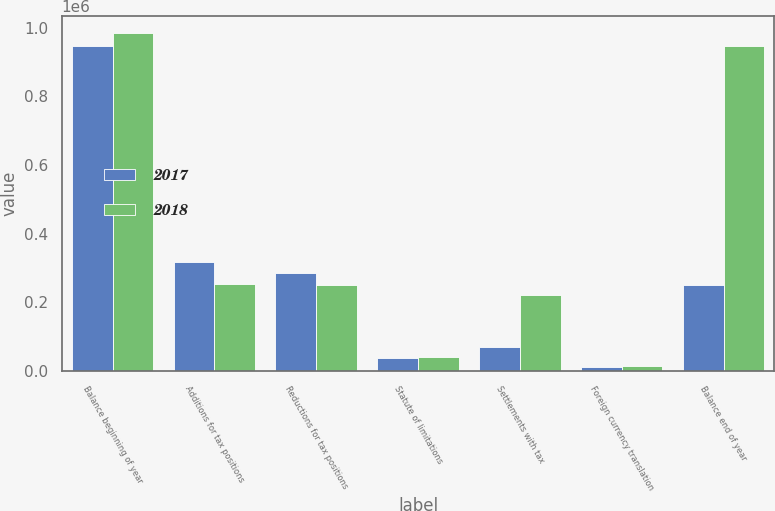Convert chart to OTSL. <chart><loc_0><loc_0><loc_500><loc_500><stacked_bar_chart><ecel><fcel>Balance beginning of year<fcel>Additions for tax positions<fcel>Reductions for tax positions<fcel>Statute of limitations<fcel>Settlements with tax<fcel>Foreign currency translation<fcel>Balance end of year<nl><fcel>2017<fcel>945850<fcel>317215<fcel>284711<fcel>37050<fcel>68605<fcel>11522<fcel>250135<nl><fcel>2018<fcel>985755<fcel>254274<fcel>250135<fcel>41544<fcel>221999<fcel>15178<fcel>945850<nl></chart> 